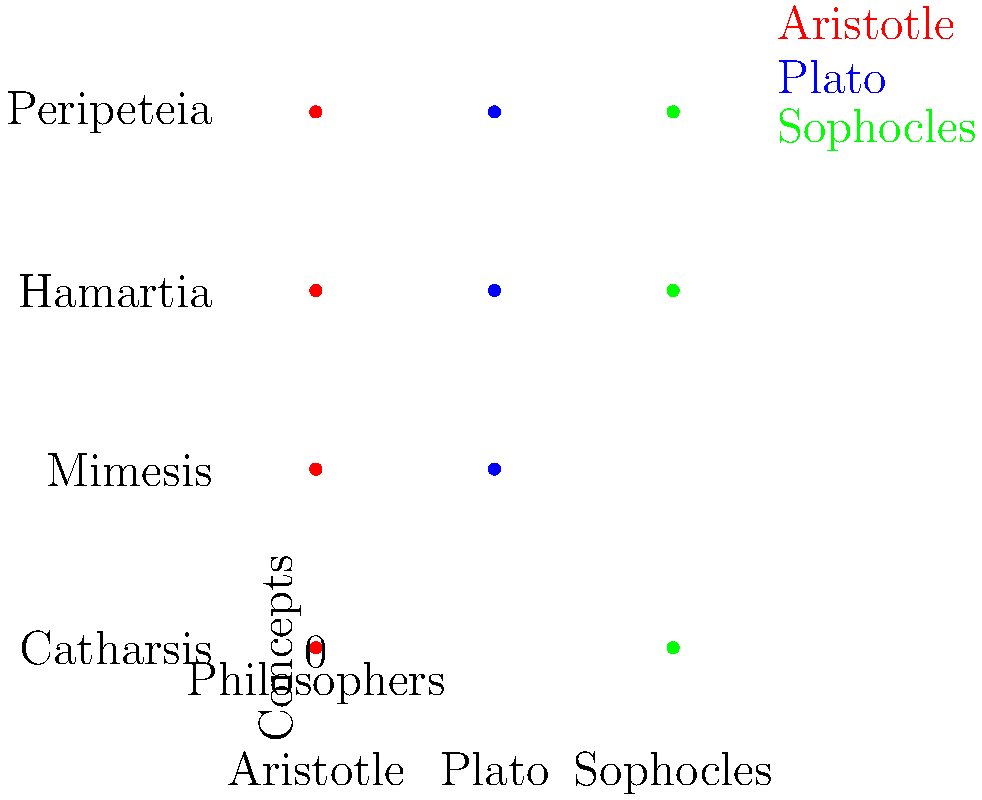Based on Rocío Orsi's analysis of tragedy in Greek philosophy, which concept is uniquely associated with Aristotle in this visual representation, and how does this concept contribute to the overall understanding of Greek tragedy? To answer this question, let's analyze the visual representation step by step:

1. The graph shows three philosophers: Aristotle, Plato, and Sophocles.
2. Four key concepts are represented: Catharsis, Mimesis, Hamartia, and Peripeteia.
3. Each philosopher is associated with different concepts, indicated by colored dots.

4. Examining Aristotle's column (red dots):
   - Aristotle is associated with all four concepts.

5. Comparing to Plato (blue dots):
   - Plato is associated with Mimesis, Hamartia, and Peripeteia, but not Catharsis.

6. Comparing to Sophocles (green dots):
   - Sophocles is associated with Catharsis, Hamartia, and Peripeteia, but not Mimesis.

7. The unique concept for Aristotle is Catharsis, as it's the only concept not shared by either Plato or Sophocles.

8. Contribution to understanding Greek tragedy:
   - Catharsis, in Aristotle's Poetics, refers to the purification or purgation of emotions (particularly pity and fear) through the experience of tragedy.
   - This concept is crucial as it explains the psychological and emotional effect of tragedy on the audience.
   - It provides a purpose for tragedy beyond mere entertainment, suggesting that it can have a beneficial effect on the psyche of the viewers.

9. Orsi's analysis likely emphasizes how Aristotle's unique focus on catharsis adds depth to the understanding of tragedy's role in Greek society and philosophy.
Answer: Catharsis; it explains the emotional purification effect of tragedy on the audience. 